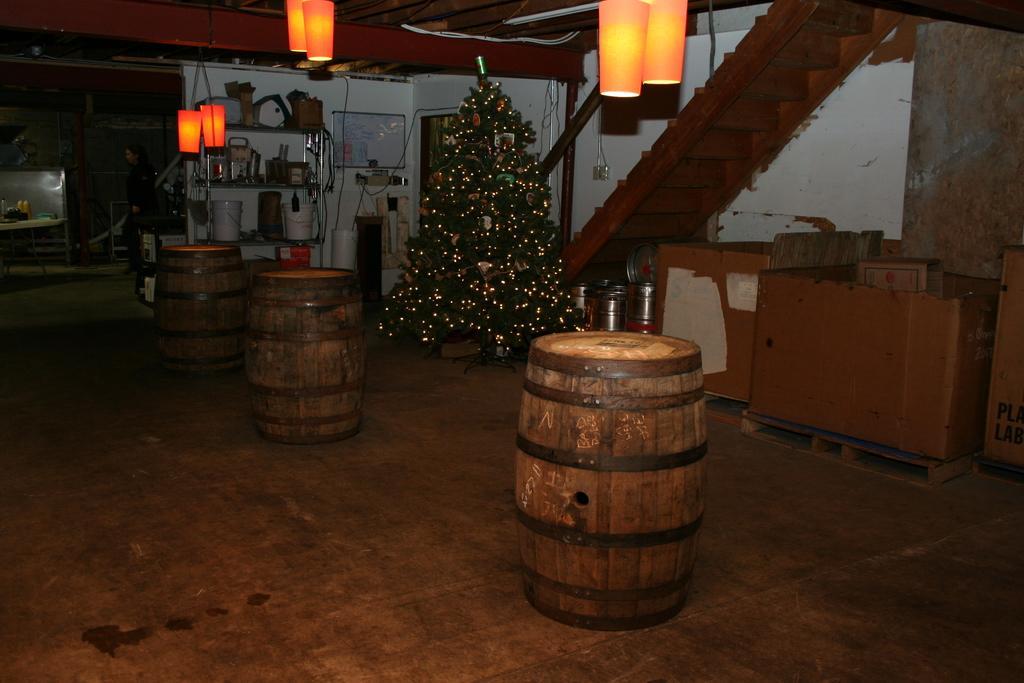How would you summarize this image in a sentence or two? In the center of the image we can see barrels and an xmas tree. On the right there is a table and stairs. At the top there are lights. In the background there is a shelf and we can see things placed in the shelf. On the left there is a door. 